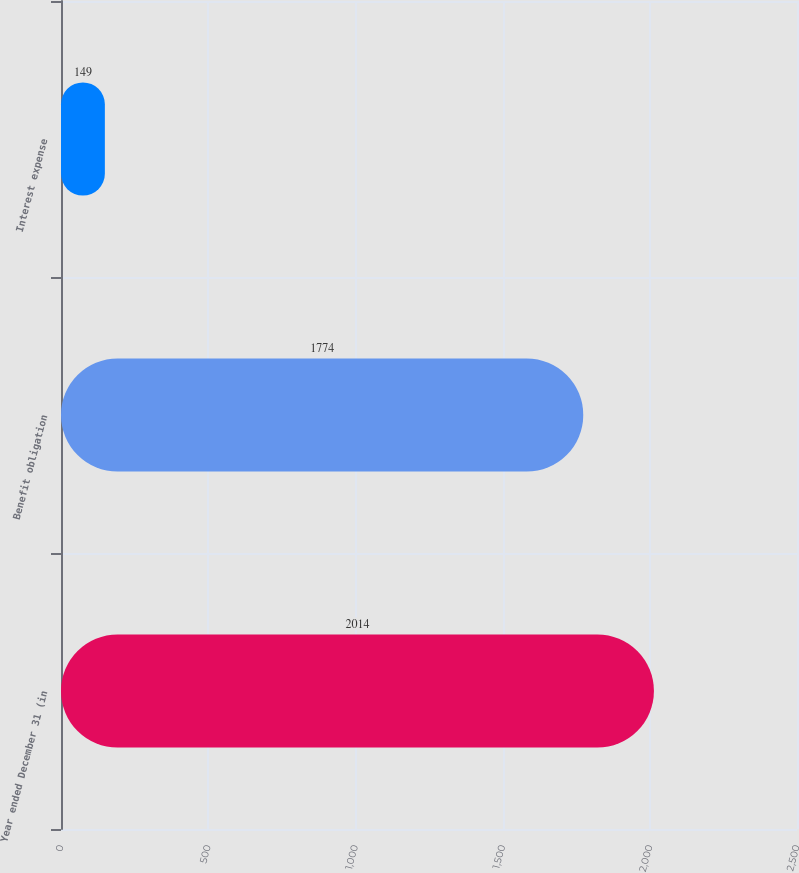Convert chart to OTSL. <chart><loc_0><loc_0><loc_500><loc_500><bar_chart><fcel>Year ended December 31 (in<fcel>Benefit obligation<fcel>Interest expense<nl><fcel>2014<fcel>1774<fcel>149<nl></chart> 